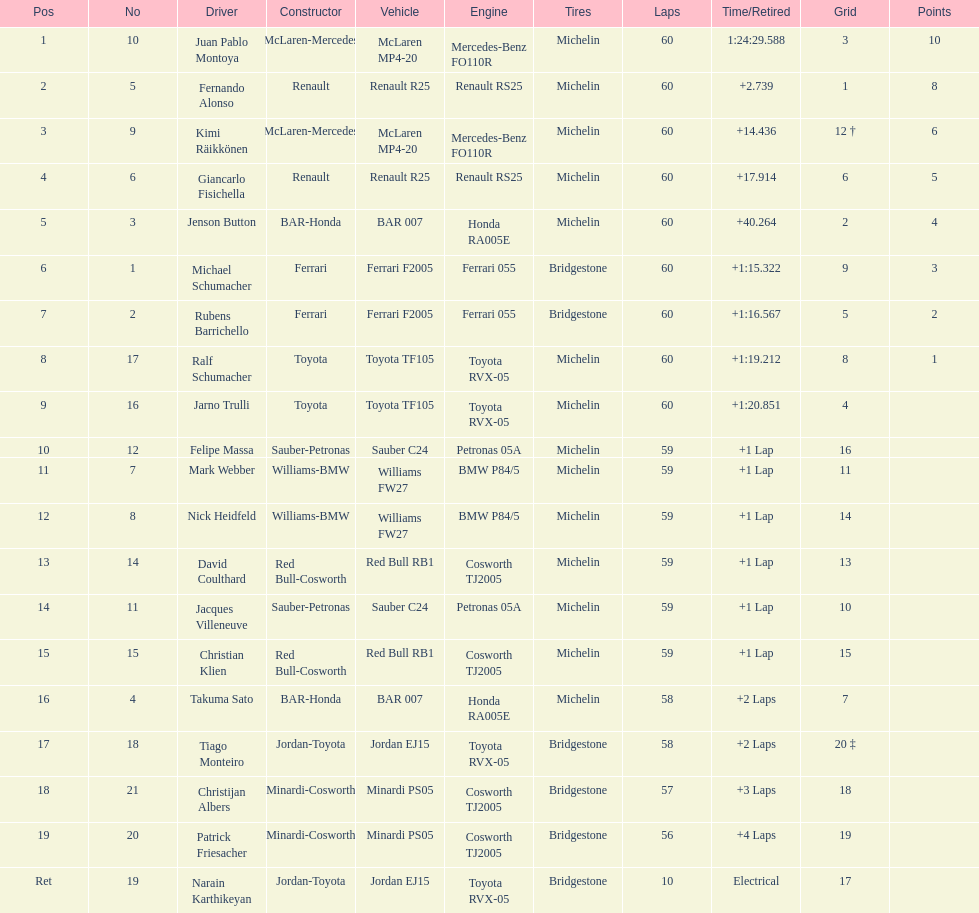Which driver has his grid at 2? Jenson Button. 